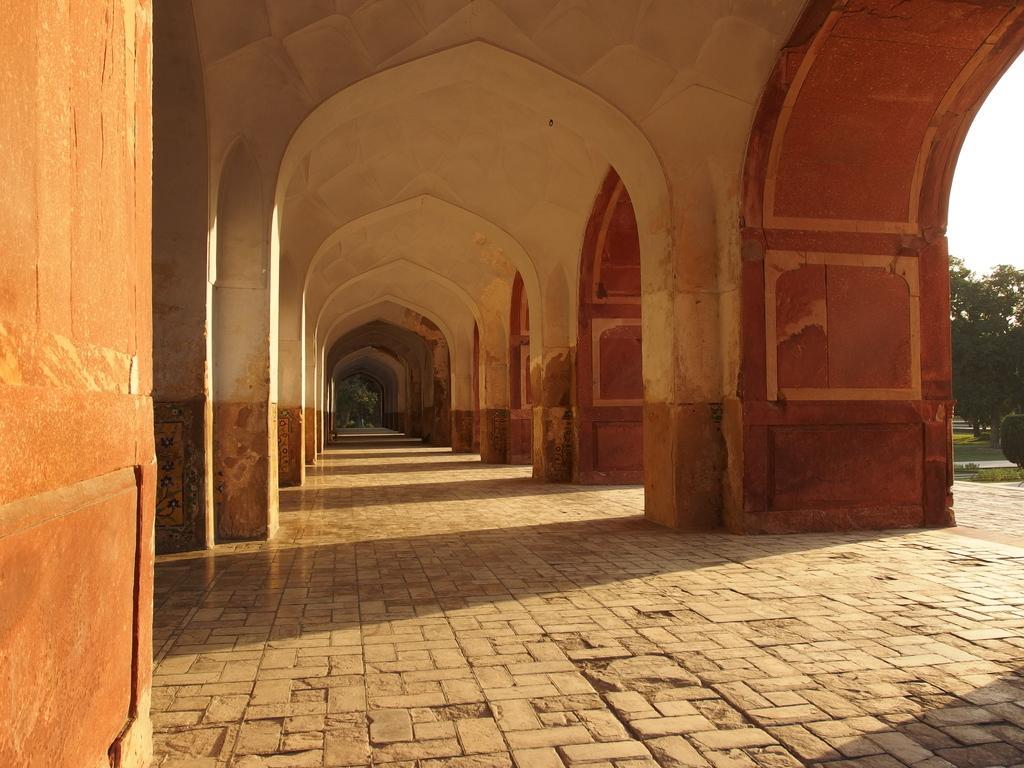In one or two sentences, can you explain what this image depicts? In this image I see the path and I see the pillars on either sides and in the background I see the trees and the bushes over here and I see the clear sky and I see the brown color thing over here. 